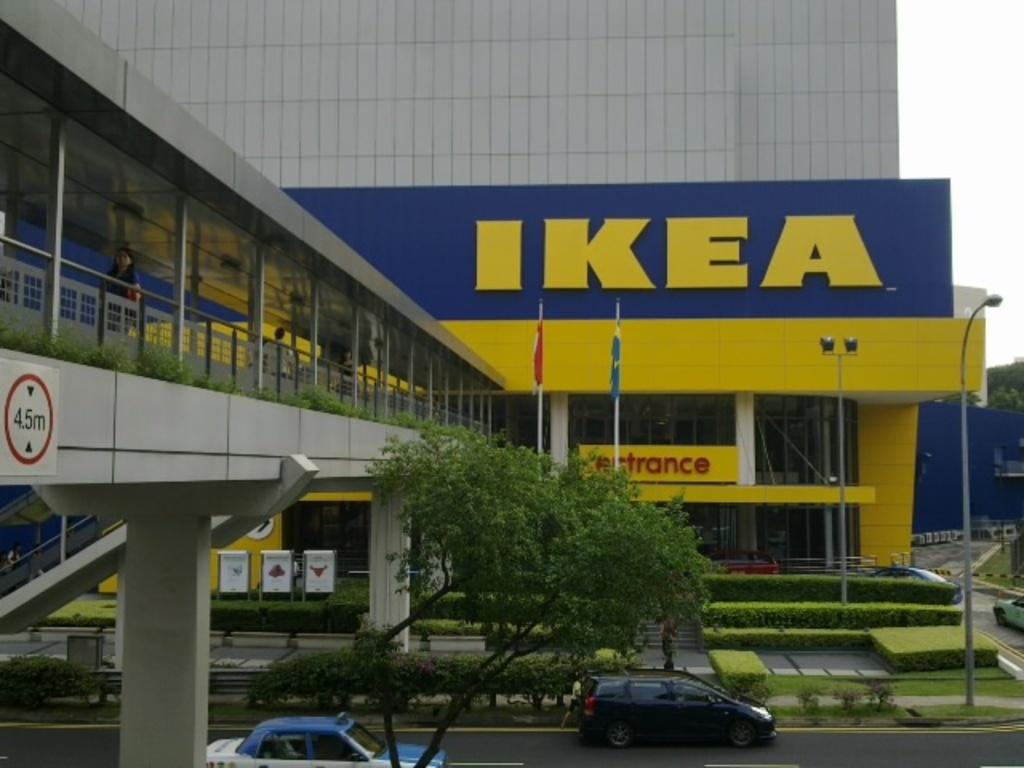What type of vehicles can be seen on the road in the image? There are cars on the road in the image. What are the banners and flags attached to in the image? The banners and flags are attached to poles in the image. What type of vegetation is present in the image? There are trees in the image. What type of barrier can be seen in the image? There is a fence in the image. What type of structure is visible in the image? There is a building in the image. What can be seen in the background of the image? The sky is visible in the background of the image. Can you see a ring on the ear of the person walking in the image? There is no person walking in the image, and no ring or ear is visible. How many feet tall is the tallest tree in the image? The image does not provide information about the height of the trees, so it cannot be determined. 